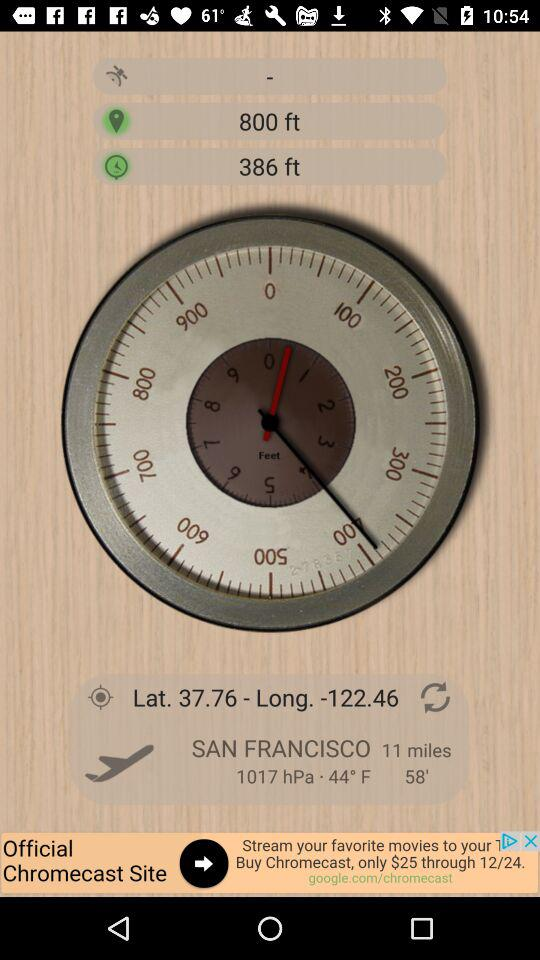What's the distance? The distance is 11 miles. 